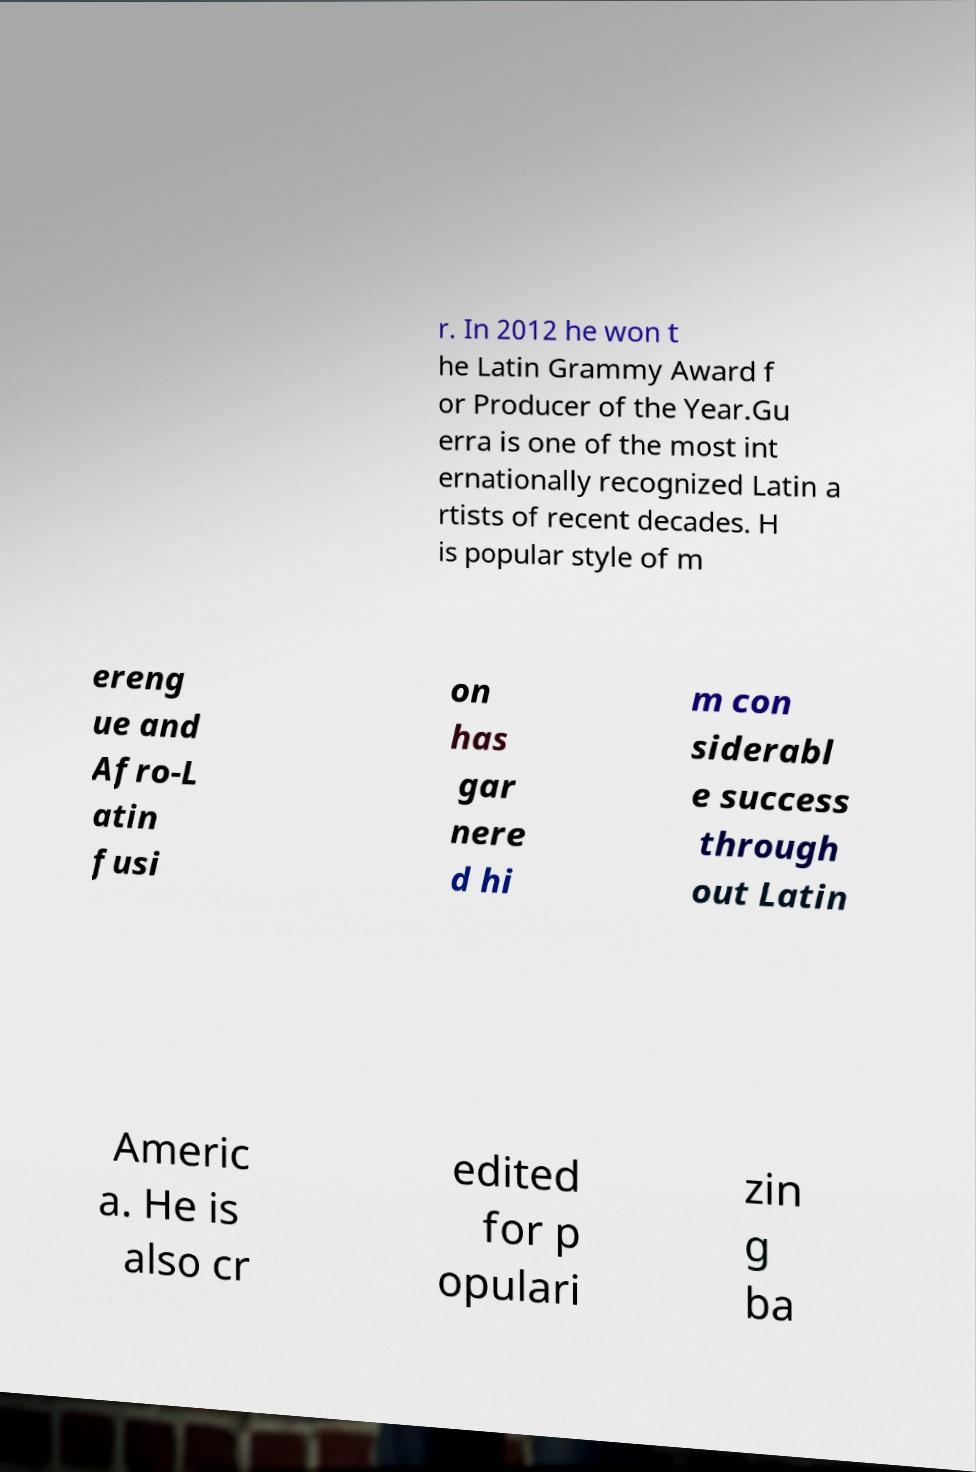Can you accurately transcribe the text from the provided image for me? r. In 2012 he won t he Latin Grammy Award f or Producer of the Year.Gu erra is one of the most int ernationally recognized Latin a rtists of recent decades. H is popular style of m ereng ue and Afro-L atin fusi on has gar nere d hi m con siderabl e success through out Latin Americ a. He is also cr edited for p opulari zin g ba 